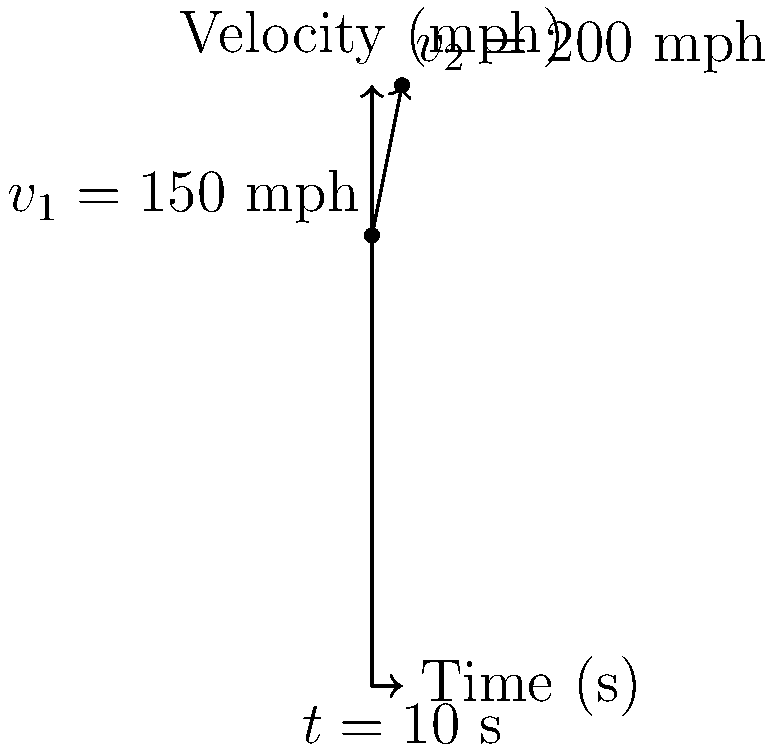During a NASCAR race, a stock car accelerates from 150 mph to 200 mph in 10 seconds. Calculate the car's acceleration in mph/s and convert it to ft/s². To solve this problem, let's follow these steps:

1) First, we need to use the acceleration formula:
   $a = \frac{v_2 - v_1}{t}$

   Where:
   $a$ = acceleration
   $v_2$ = final velocity
   $v_1$ = initial velocity
   $t$ = time

2) Plug in the values:
   $a = \frac{200 \text{ mph} - 150 \text{ mph}}{10 \text{ s}} = \frac{50 \text{ mph}}{10 \text{ s}} = 5 \text{ mph/s}$

3) Now we need to convert mph/s to ft/s²:
   - First, convert mph to ft/h: 1 mile = 5280 feet
     $5 \text{ mph/s} = 5 \times 5280 \text{ ft/h/s} = 26400 \text{ ft/h/s}$
   
   - Then, convert h to s: 1 h = 3600 s
     $26400 \text{ ft/h/s} = 26400 \div 3600 \text{ ft/s²} = 7.33 \text{ ft/s²}$

Therefore, the acceleration is 5 mph/s or 7.33 ft/s².
Answer: 5 mph/s or 7.33 ft/s² 